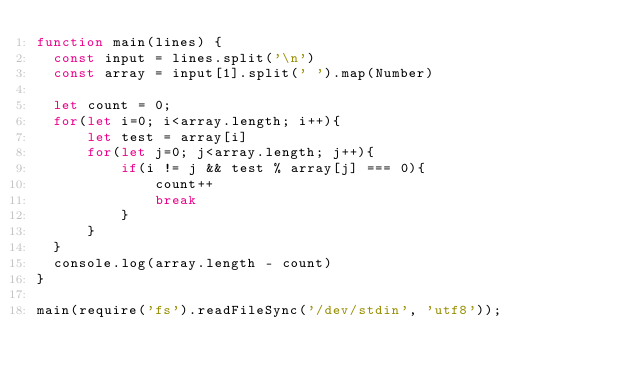<code> <loc_0><loc_0><loc_500><loc_500><_JavaScript_>function main(lines) {
  const input = lines.split('\n')
  const array = input[1].split(' ').map(Number)

  let count = 0;
  for(let i=0; i<array.length; i++){
      let test = array[i]
      for(let j=0; j<array.length; j++){
          if(i != j && test % array[j] === 0){
              count++
              break
          }
      }
  }
  console.log(array.length - count)
}

main(require('fs').readFileSync('/dev/stdin', 'utf8'));

</code> 